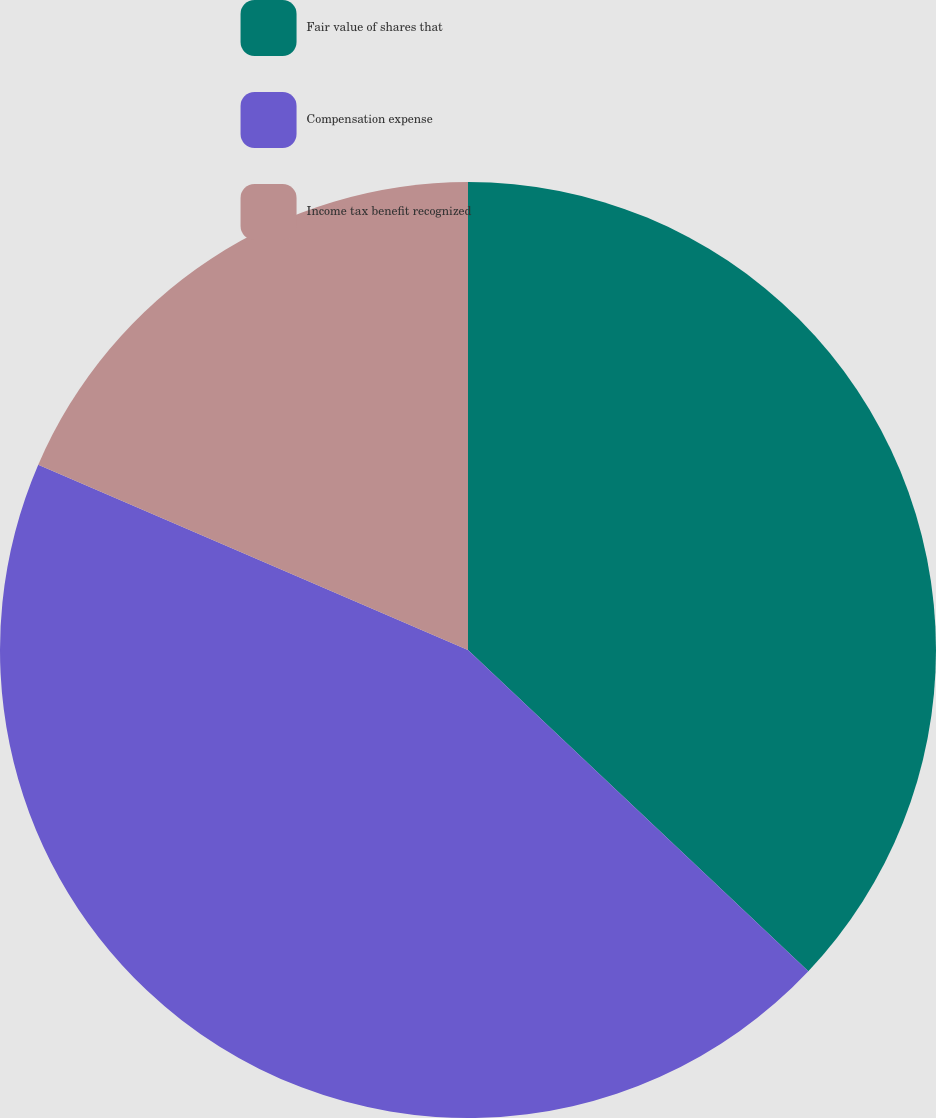<chart> <loc_0><loc_0><loc_500><loc_500><pie_chart><fcel>Fair value of shares that<fcel>Compensation expense<fcel>Income tax benefit recognized<nl><fcel>37.04%<fcel>44.44%<fcel>18.52%<nl></chart> 